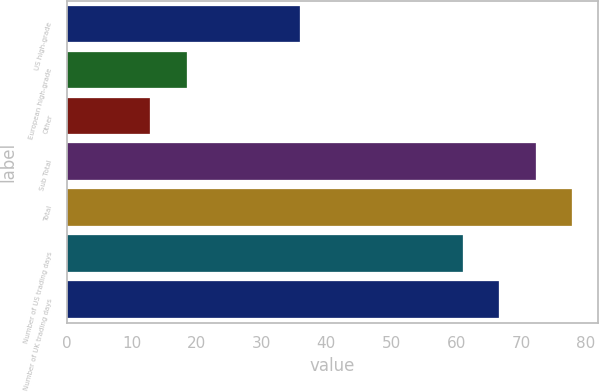Convert chart. <chart><loc_0><loc_0><loc_500><loc_500><bar_chart><fcel>US high-grade<fcel>European high-grade<fcel>Other<fcel>Sub Total<fcel>Total<fcel>Number of US trading days<fcel>Number of UK trading days<nl><fcel>35.9<fcel>18.54<fcel>12.9<fcel>72.28<fcel>77.92<fcel>61<fcel>66.64<nl></chart> 